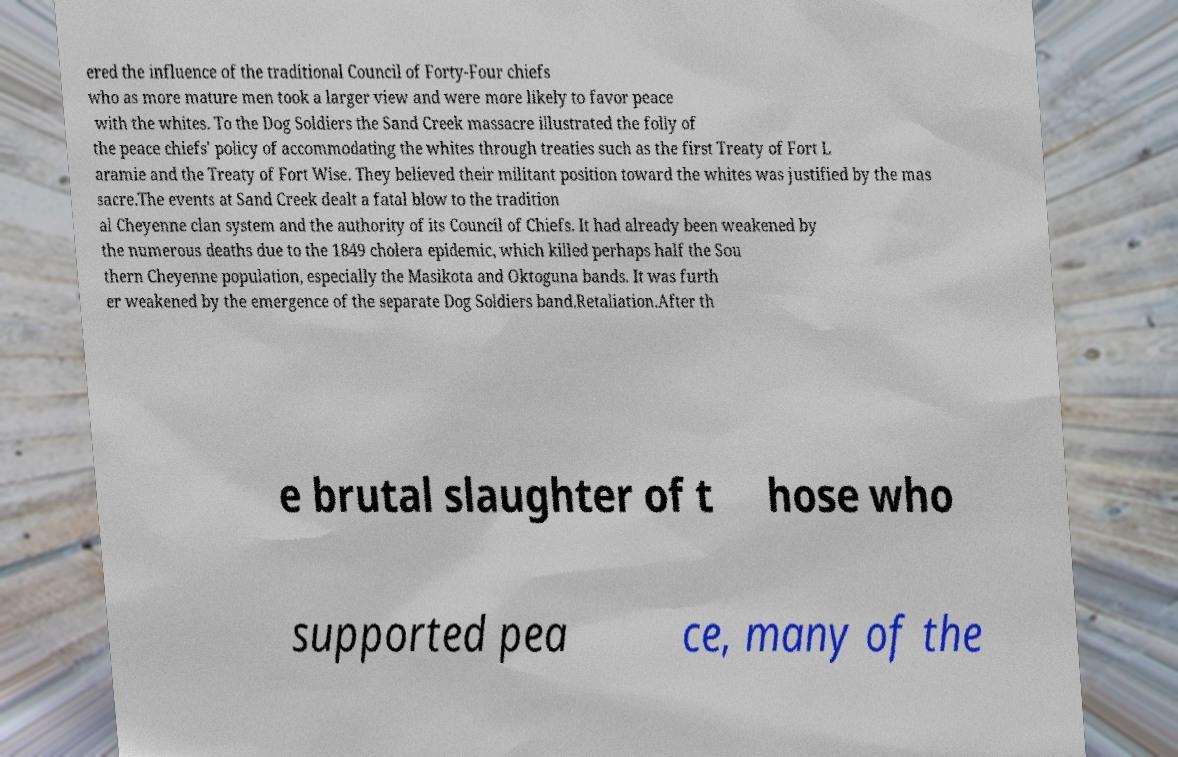For documentation purposes, I need the text within this image transcribed. Could you provide that? ered the influence of the traditional Council of Forty-Four chiefs who as more mature men took a larger view and were more likely to favor peace with the whites. To the Dog Soldiers the Sand Creek massacre illustrated the folly of the peace chiefs' policy of accommodating the whites through treaties such as the first Treaty of Fort L aramie and the Treaty of Fort Wise. They believed their militant position toward the whites was justified by the mas sacre.The events at Sand Creek dealt a fatal blow to the tradition al Cheyenne clan system and the authority of its Council of Chiefs. It had already been weakened by the numerous deaths due to the 1849 cholera epidemic, which killed perhaps half the Sou thern Cheyenne population, especially the Masikota and Oktoguna bands. It was furth er weakened by the emergence of the separate Dog Soldiers band.Retaliation.After th e brutal slaughter of t hose who supported pea ce, many of the 